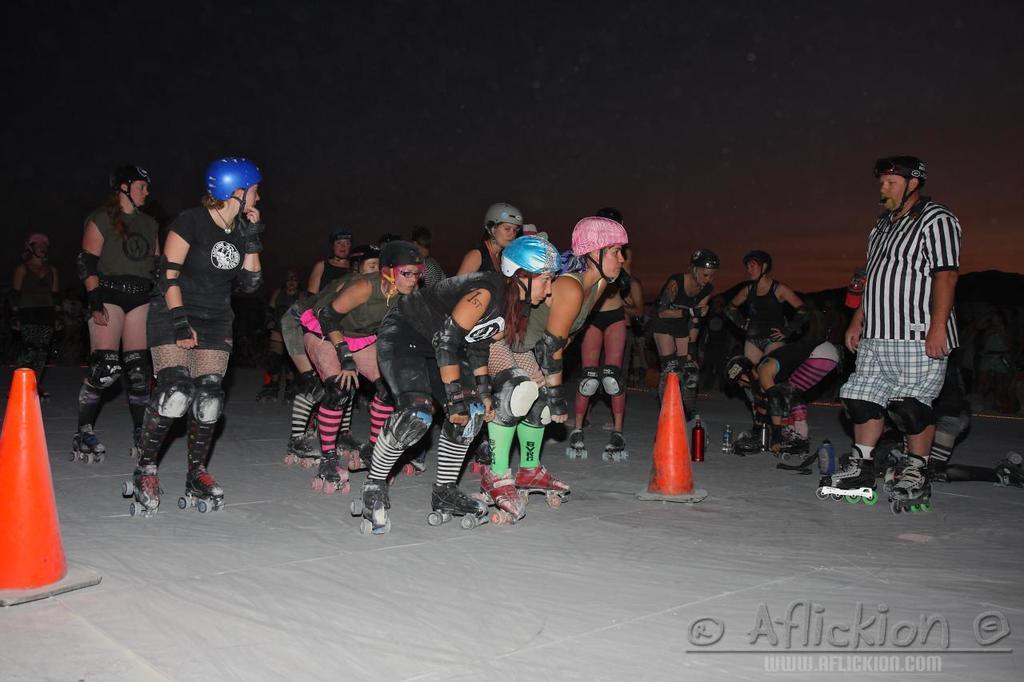How would you summarize this image in a sentence or two? In this image we can see few people wearing skates and helmets and there are bottles, orange color objects on the ground and in the background there are mountains and the sky. 